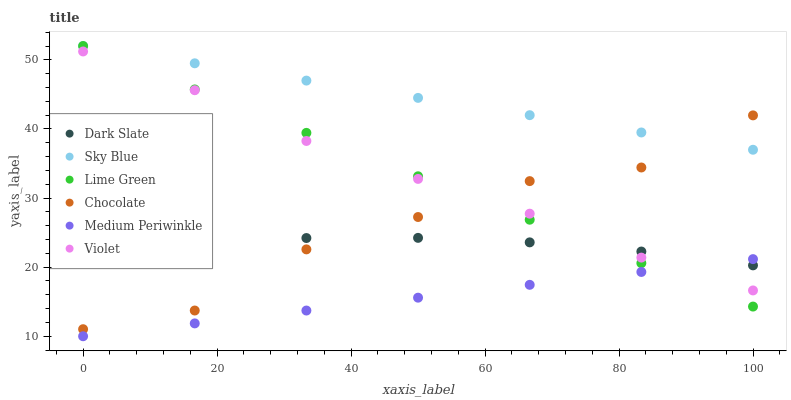Does Medium Periwinkle have the minimum area under the curve?
Answer yes or no. Yes. Does Sky Blue have the maximum area under the curve?
Answer yes or no. Yes. Does Chocolate have the minimum area under the curve?
Answer yes or no. No. Does Chocolate have the maximum area under the curve?
Answer yes or no. No. Is Medium Periwinkle the smoothest?
Answer yes or no. Yes. Is Chocolate the roughest?
Answer yes or no. Yes. Is Dark Slate the smoothest?
Answer yes or no. No. Is Dark Slate the roughest?
Answer yes or no. No. Does Medium Periwinkle have the lowest value?
Answer yes or no. Yes. Does Chocolate have the lowest value?
Answer yes or no. No. Does Lime Green have the highest value?
Answer yes or no. Yes. Does Chocolate have the highest value?
Answer yes or no. No. Is Dark Slate less than Sky Blue?
Answer yes or no. Yes. Is Sky Blue greater than Violet?
Answer yes or no. Yes. Does Lime Green intersect Medium Periwinkle?
Answer yes or no. Yes. Is Lime Green less than Medium Periwinkle?
Answer yes or no. No. Is Lime Green greater than Medium Periwinkle?
Answer yes or no. No. Does Dark Slate intersect Sky Blue?
Answer yes or no. No. 